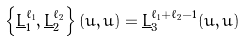Convert formula to latex. <formula><loc_0><loc_0><loc_500><loc_500>\left \{ \underline { L } \null _ { 1 } ^ { \ell _ { 1 } } , \underline { L } \null _ { 2 } ^ { \ell _ { 2 } } \right \} ( u , \bar { u } ) = \underline { L } \null _ { 3 } ^ { \ell _ { 1 } + \ell _ { 2 } - 1 } ( u , \bar { u } )</formula> 